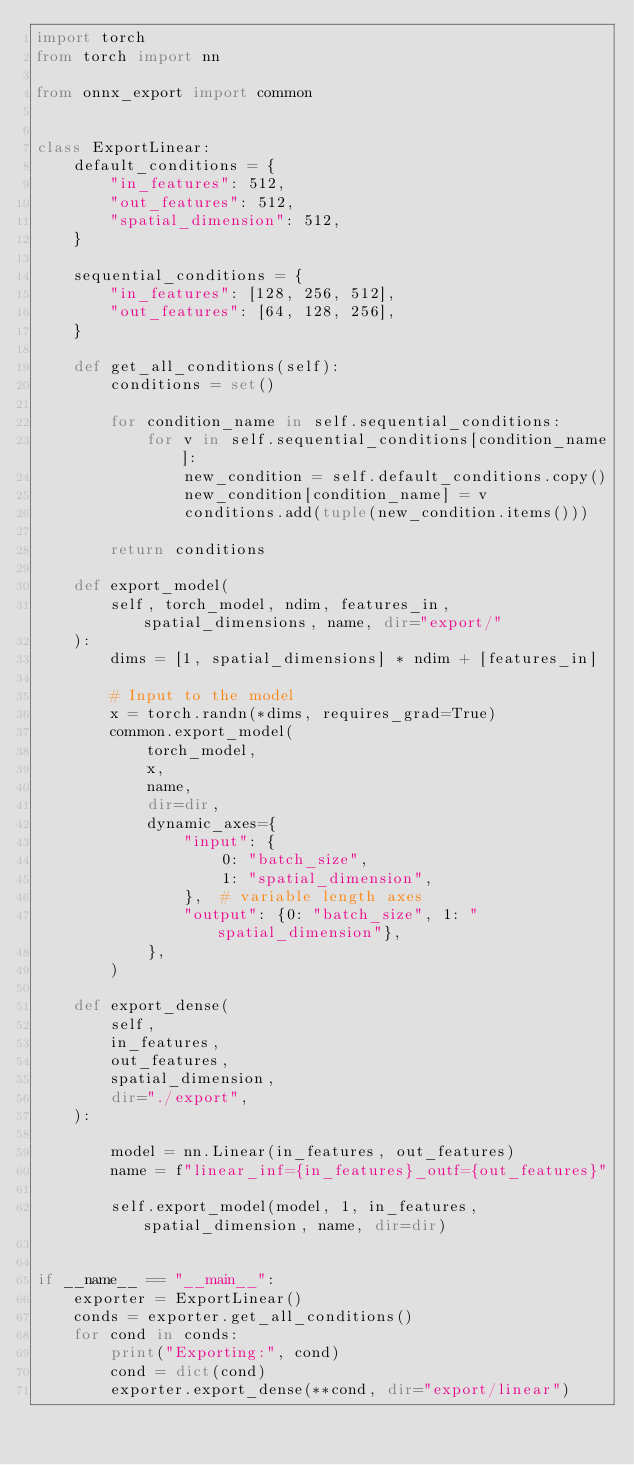Convert code to text. <code><loc_0><loc_0><loc_500><loc_500><_Python_>import torch
from torch import nn

from onnx_export import common


class ExportLinear:
    default_conditions = {
        "in_features": 512,
        "out_features": 512,
        "spatial_dimension": 512,
    }

    sequential_conditions = {
        "in_features": [128, 256, 512],
        "out_features": [64, 128, 256],
    }

    def get_all_conditions(self):
        conditions = set()

        for condition_name in self.sequential_conditions:
            for v in self.sequential_conditions[condition_name]:
                new_condition = self.default_conditions.copy()
                new_condition[condition_name] = v
                conditions.add(tuple(new_condition.items()))

        return conditions

    def export_model(
        self, torch_model, ndim, features_in, spatial_dimensions, name, dir="export/"
    ):
        dims = [1, spatial_dimensions] * ndim + [features_in]

        # Input to the model
        x = torch.randn(*dims, requires_grad=True)
        common.export_model(
            torch_model,
            x,
            name,
            dir=dir,
            dynamic_axes={
                "input": {
                    0: "batch_size",
                    1: "spatial_dimension",
                },  # variable length axes
                "output": {0: "batch_size", 1: "spatial_dimension"},
            },
        )

    def export_dense(
        self,
        in_features,
        out_features,
        spatial_dimension,
        dir="./export",
    ):

        model = nn.Linear(in_features, out_features)
        name = f"linear_inf={in_features}_outf={out_features}"

        self.export_model(model, 1, in_features, spatial_dimension, name, dir=dir)


if __name__ == "__main__":
    exporter = ExportLinear()
    conds = exporter.get_all_conditions()
    for cond in conds:
        print("Exporting:", cond)
        cond = dict(cond)
        exporter.export_dense(**cond, dir="export/linear")
</code> 